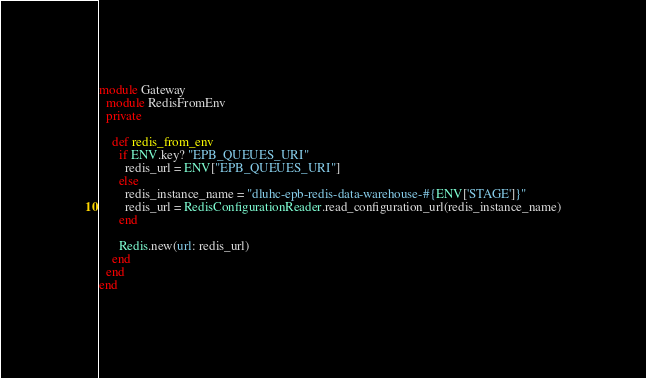Convert code to text. <code><loc_0><loc_0><loc_500><loc_500><_Ruby_>module Gateway
  module RedisFromEnv
  private

    def redis_from_env
      if ENV.key? "EPB_QUEUES_URI"
        redis_url = ENV["EPB_QUEUES_URI"]
      else
        redis_instance_name = "dluhc-epb-redis-data-warehouse-#{ENV['STAGE']}"
        redis_url = RedisConfigurationReader.read_configuration_url(redis_instance_name)
      end

      Redis.new(url: redis_url)
    end
  end
end
</code> 